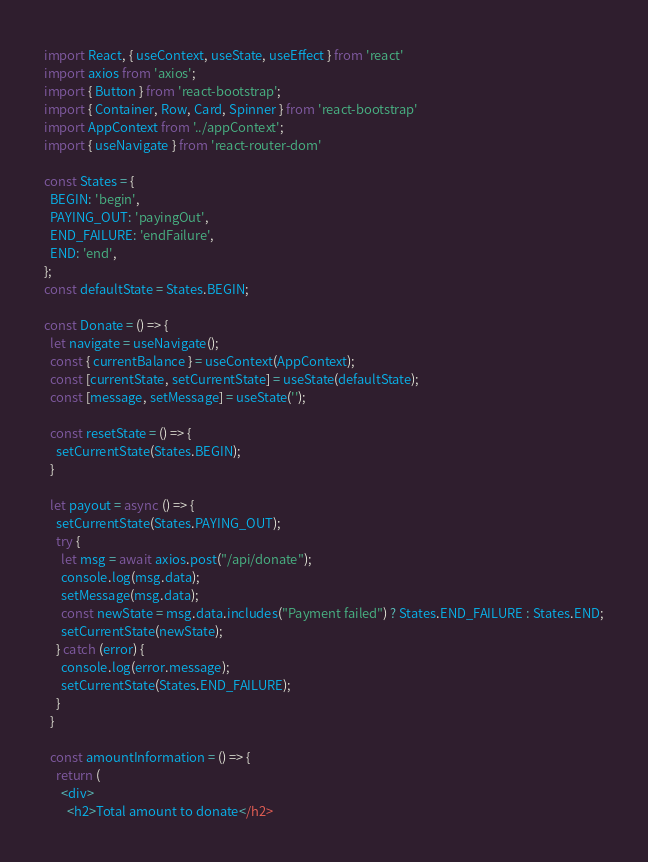Convert code to text. <code><loc_0><loc_0><loc_500><loc_500><_JavaScript_>import React, { useContext, useState, useEffect } from 'react'
import axios from 'axios';
import { Button } from 'react-bootstrap';
import { Container, Row, Card, Spinner } from 'react-bootstrap'
import AppContext from '../appContext';
import { useNavigate } from 'react-router-dom'

const States = {
  BEGIN: 'begin',
  PAYING_OUT: 'payingOut',
  END_FAILURE: 'endFailure',
  END: 'end',
};
const defaultState = States.BEGIN;

const Donate = () => {
  let navigate = useNavigate();
  const { currentBalance } = useContext(AppContext);
  const [currentState, setCurrentState] = useState(defaultState);
  const [message, setMessage] = useState('');

  const resetState = () => {
    setCurrentState(States.BEGIN);
  }

  let payout = async () => {
    setCurrentState(States.PAYING_OUT);
    try {
      let msg = await axios.post("/api/donate");
      console.log(msg.data);
      setMessage(msg.data);
      const newState = msg.data.includes("Payment failed") ? States.END_FAILURE : States.END;
      setCurrentState(newState);
    } catch (error) {
      console.log(error.message);
      setCurrentState(States.END_FAILURE);
    }
  }

  const amountInformation = () => {
    return (
      <div>
        <h2>Total amount to donate</h2></code> 